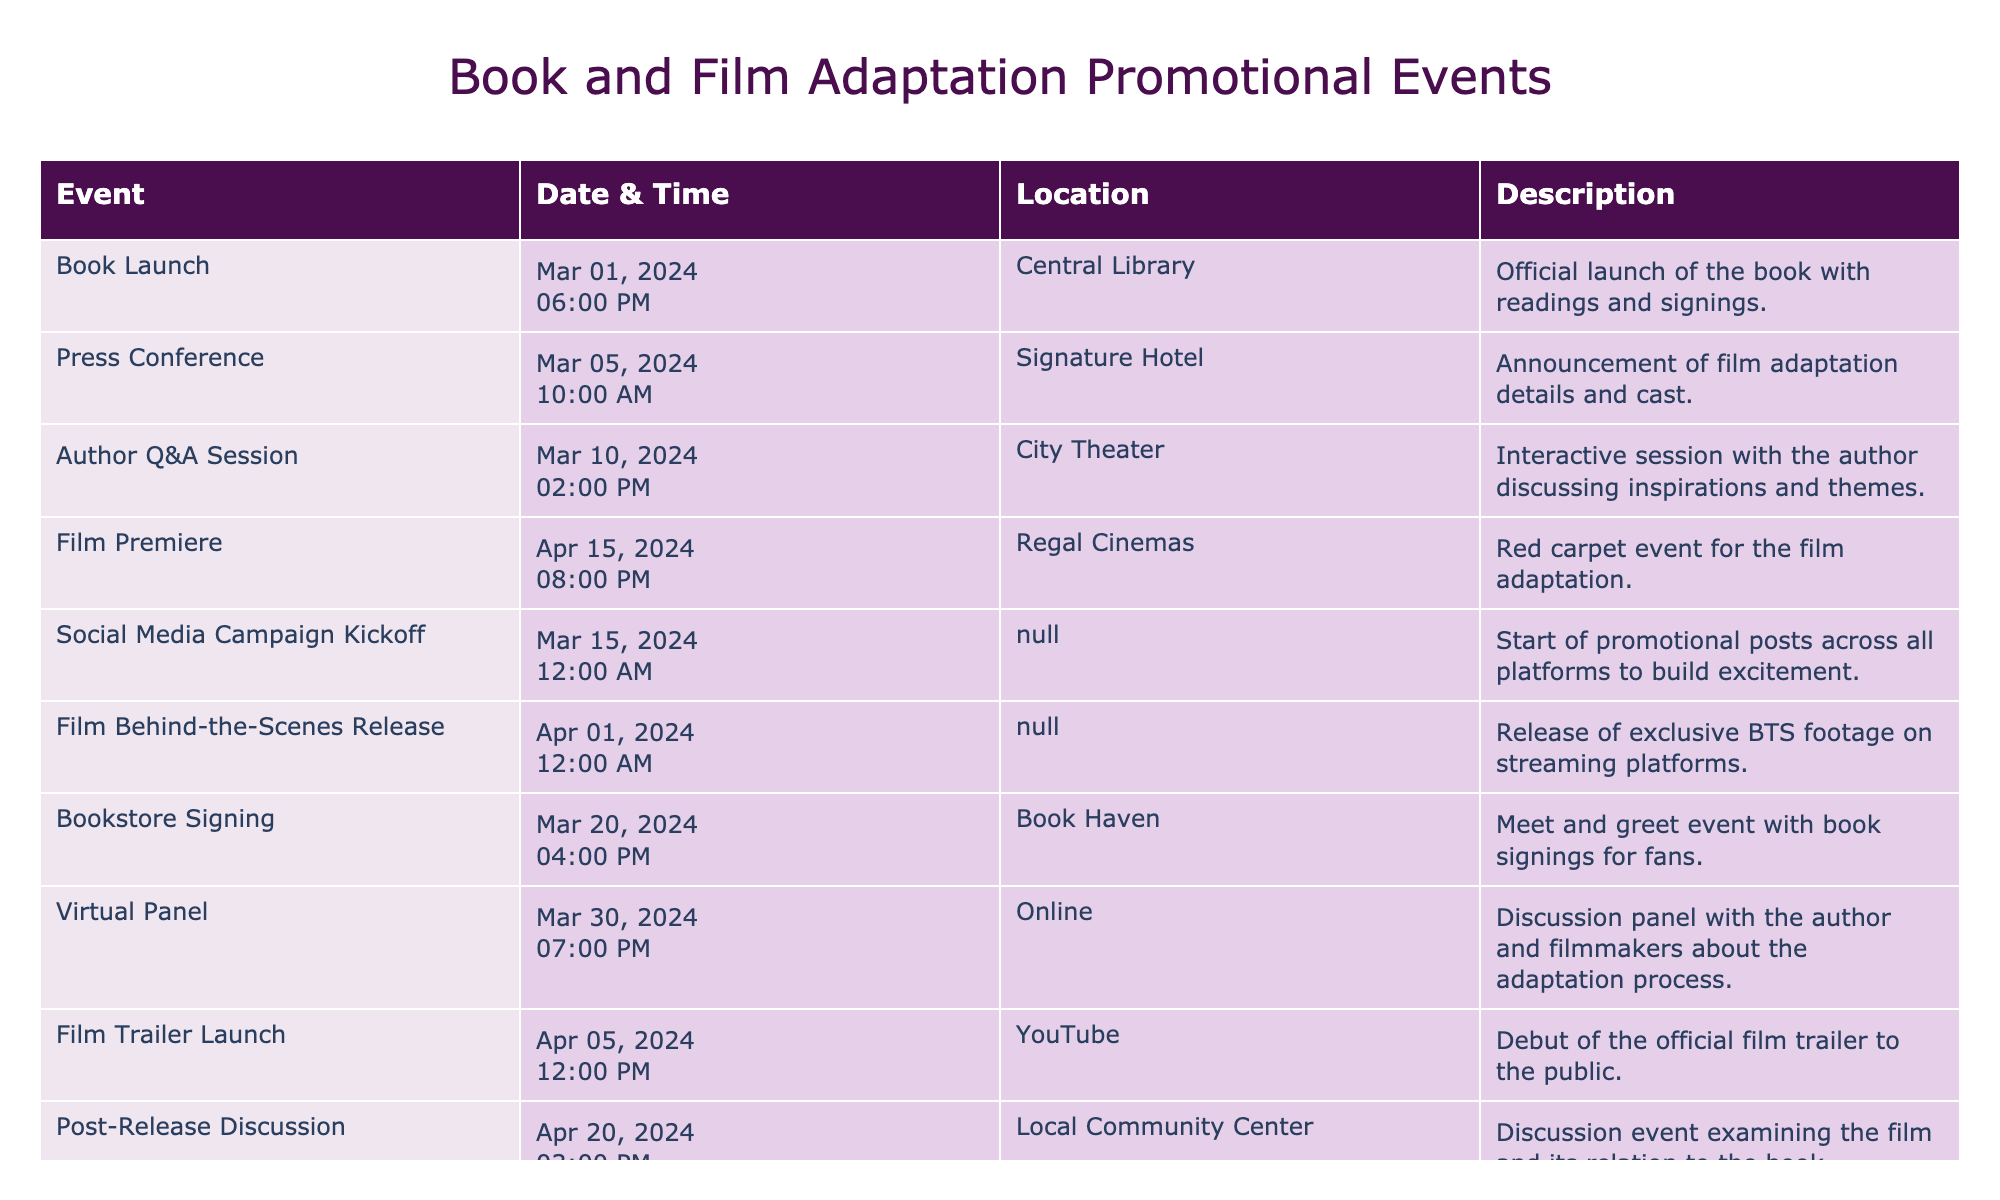What is the date of the Film Premiere event? The Film Premiere event is scheduled for April 15, 2024, as per the information in the table.
Answer: April 15, 2024 How many days are there between the Book Launch and the Film Premiere? The Book Launch is on March 1, 2024, and the Film Premiere is on April 15, 2024. Counting the days in March (31 days) gives us 30 days until March 31, plus 15 days in April, which sums to a total of 30 + 15 = 45 days.
Answer: 45 days Is there a promotional event happening on March 15, 2024? Yes, there is a Social Media Campaign Kickoff event scheduled for March 15, 2024, according to the table.
Answer: Yes What time does the Author Q&A Session start? The Author Q&A Session is listed as starting at 14:00 (or 2:00 PM) on March 10, 2024.
Answer: 2:00 PM What is the total number of events scheduled for March 2024? There are four events scheduled for March 2024: Book Launch (March 1), Social Media Campaign Kickoff (March 15), Bookstore Signing (March 20), and Author Q&A Session (March 10). This makes a total of four events.
Answer: 4 events What is the location of the Press Conference? The Press Conference will be held at Signature Hotel, as specified in the table.
Answer: Signature Hotel How many events are scheduled for April 2024? In April 2024, there are three events scheduled: Film Premiere (April 15), Film Trailer Launch (April 5), and Post-Release Discussion (April 20). Therefore, there are three events in total for April.
Answer: 3 events True or False: The Film Behind-the-Scenes Release occurs before the Film Premiere. True, the Film Behind-the-Scenes Release is on April 1, 2024, while the Film Premiere is on April 15, 2024.
Answer: True What is the description of the Virtual Panel event? The Virtual Panel event is described as a discussion panel with the author and filmmakers about the adaptation process. This is mentioned in the event description provided in the table.
Answer: Discussion panel with the author and filmmakers about the adaptation process 